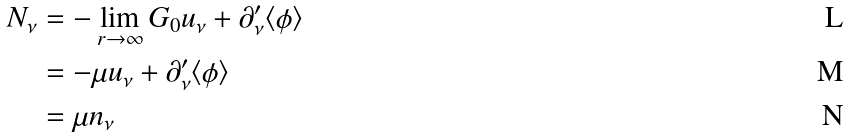Convert formula to latex. <formula><loc_0><loc_0><loc_500><loc_500>N _ { \nu } & = - \lim _ { r \to \infty } G _ { 0 } u _ { \nu } + \partial ^ { \prime } _ { \nu } \langle \phi \rangle \\ & = - \mu u _ { \nu } + \partial ^ { \prime } _ { \nu } \langle \phi \rangle \\ & = \mu n _ { \nu } \,</formula> 